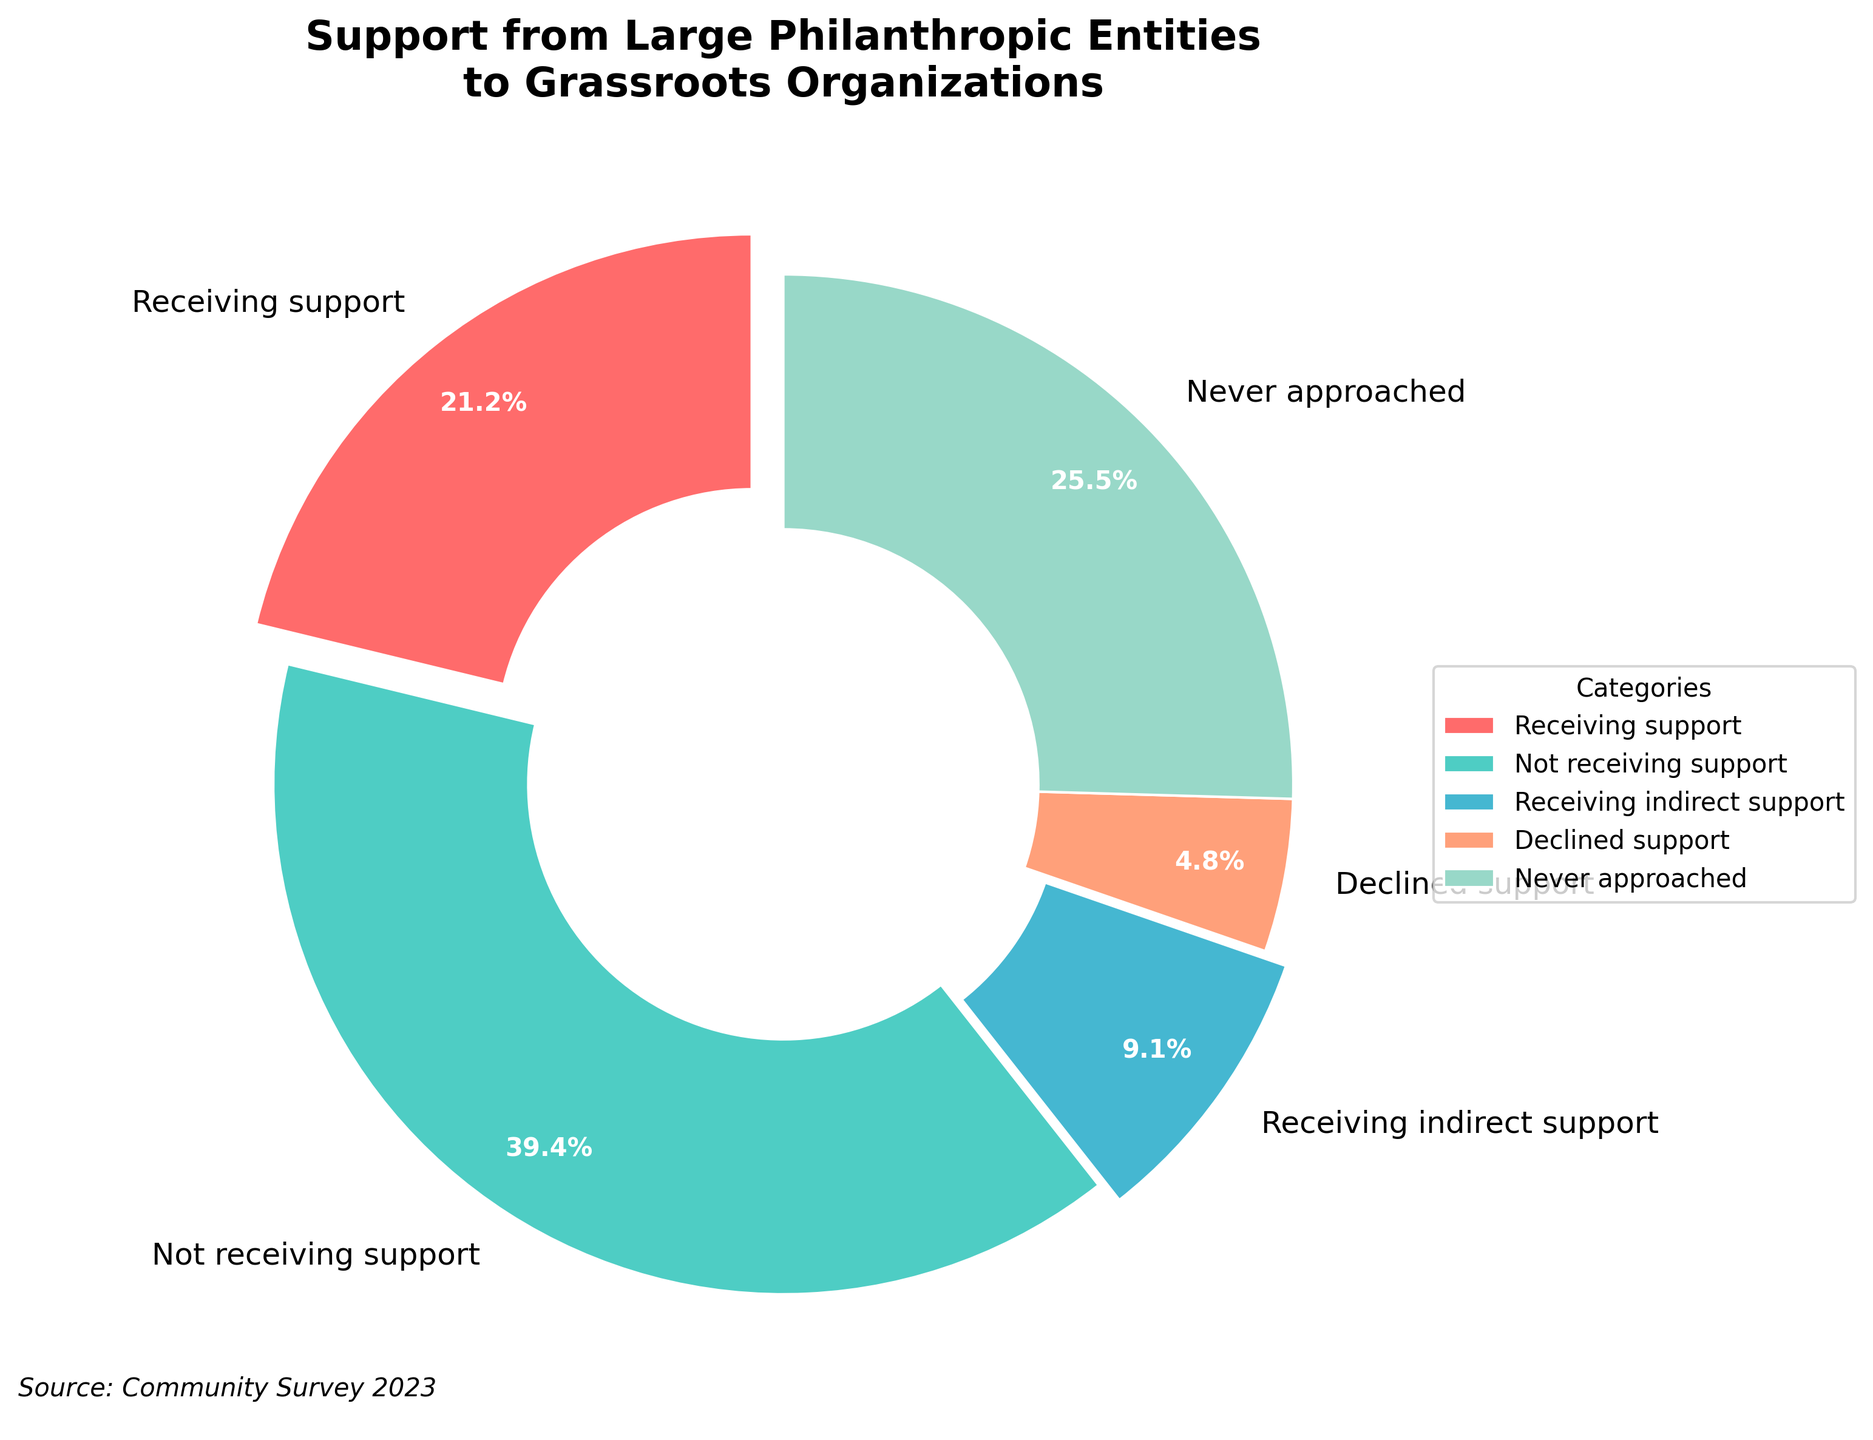What percentage of grassroots organizations is not receiving direct support from large philanthropic entities? By adding the percentages of the categories "Not receiving support," "Receiving indirect support," and "Never approached," we get 65% + 15% + 42% = 122%.
Answer: 122% Which category has the highest percentage of grassroots organizations? The pie chart shows that “Never approached” has the highest percentage at 42%.
Answer: Never approached How many categories have a percentage lower than 10%? From the figure, only one category, "Declined support," has a percentage lower than 10%; it is 8%.
Answer: One What is the approximate difference between the percentage of organizations receiving direct support and those never approached by large philanthropic entities? The percentage receiving direct support is 35%, and those never approached is 42%. The difference is 42% - 35% = 7%.
Answer: 7% What is the combined percentage of organizations receiving some form of support (either direct or indirect)? Adding the percentages of "Receiving support" and "Receiving indirect support" gives us 35% + 15% = 50%.
Answer: 50% What category has the second highest percentage of grassroots organizations? "Not receiving support" has the second highest percentage at 65%.
Answer: Not receiving support If you combine the percentages of "Declined support" and "Receiving indirect support," how does the result compare to the percentage of those "Receiving support"? Adding the percentages of "Declined support" (8%) and "Receiving indirect support" (15%) gives 8% + 15% = 23%, which is less than 35% (the percentage of "Receiving support").
Answer: Less than What color represents the category "Receiving support"? The pie chart shows "Receiving support" in red.
Answer: Red 